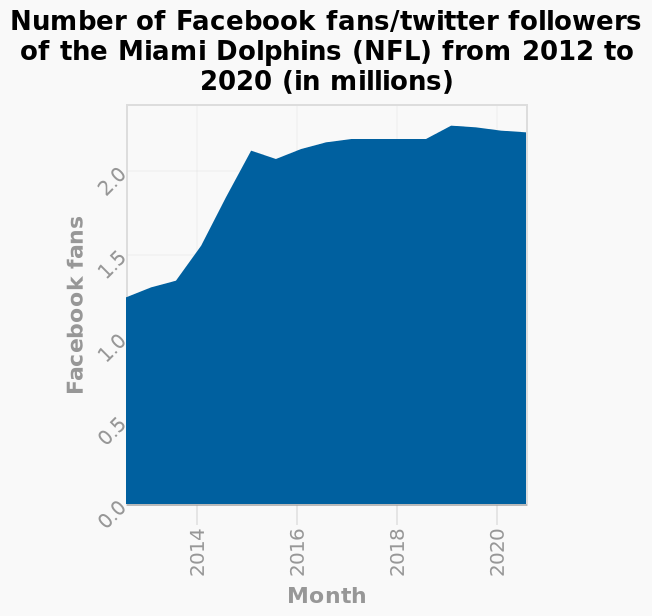<image>
please enumerates aspects of the construction of the chart Number of Facebook fans/twitter followers of the Miami Dolphins (NFL) from 2012 to 2020 (in millions) is a area diagram. There is a linear scale of range 0.0 to 2.0 on the y-axis, marked Facebook fans. There is a linear scale of range 2014 to 2020 along the x-axis, labeled Month. What was the lowest number of Facebook fans and Twitter followers for the Miami Dolphins in 2012?  The lowest number of Facebook fans and Twitter followers for the Miami Dolphins in 2012 was 1.3 million fans. 